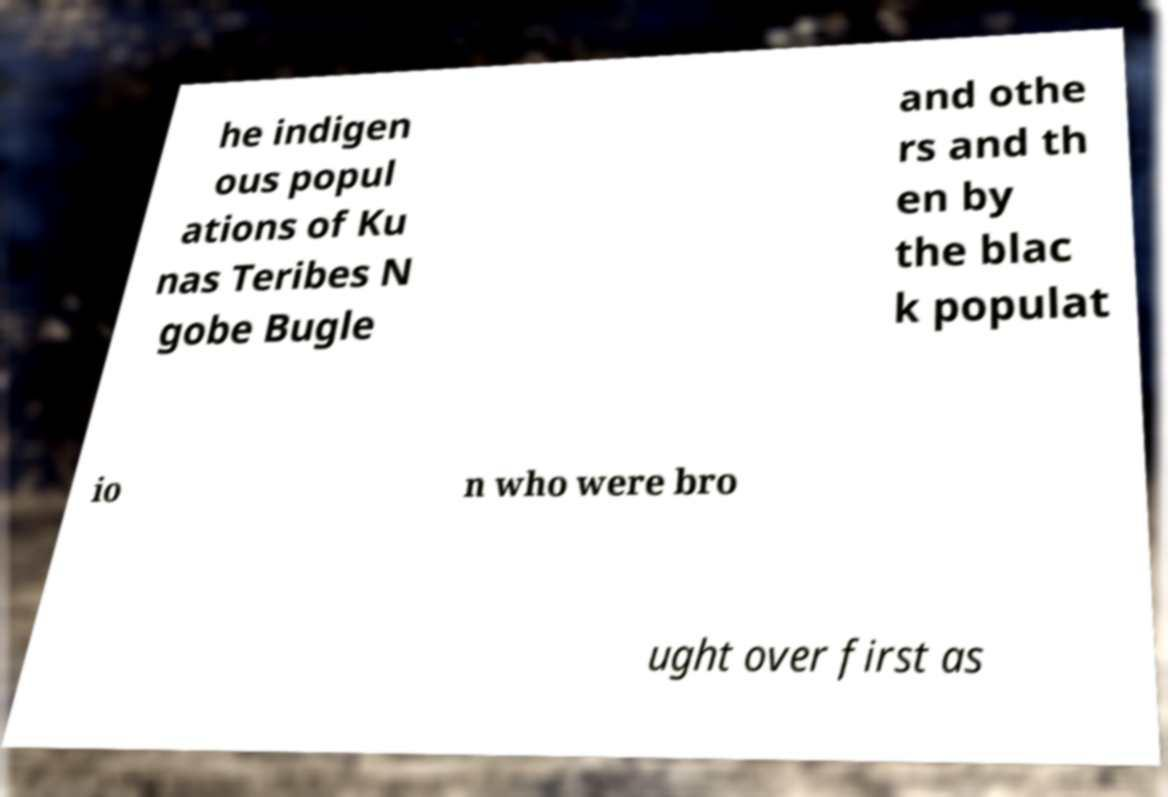Can you read and provide the text displayed in the image?This photo seems to have some interesting text. Can you extract and type it out for me? he indigen ous popul ations of Ku nas Teribes N gobe Bugle and othe rs and th en by the blac k populat io n who were bro ught over first as 